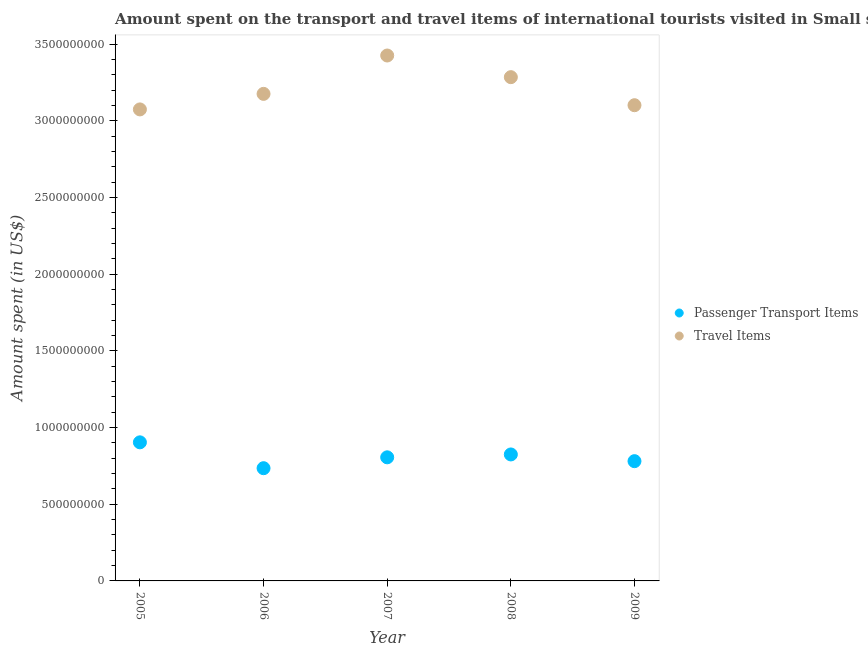How many different coloured dotlines are there?
Give a very brief answer. 2. What is the amount spent in travel items in 2008?
Offer a very short reply. 3.29e+09. Across all years, what is the maximum amount spent in travel items?
Offer a terse response. 3.43e+09. Across all years, what is the minimum amount spent in travel items?
Offer a very short reply. 3.08e+09. In which year was the amount spent in travel items minimum?
Your response must be concise. 2005. What is the total amount spent on passenger transport items in the graph?
Provide a succinct answer. 4.05e+09. What is the difference between the amount spent on passenger transport items in 2005 and that in 2007?
Ensure brevity in your answer.  9.78e+07. What is the difference between the amount spent on passenger transport items in 2005 and the amount spent in travel items in 2008?
Your answer should be compact. -2.38e+09. What is the average amount spent in travel items per year?
Provide a succinct answer. 3.21e+09. In the year 2006, what is the difference between the amount spent on passenger transport items and amount spent in travel items?
Offer a terse response. -2.44e+09. What is the ratio of the amount spent on passenger transport items in 2007 to that in 2009?
Give a very brief answer. 1.03. Is the amount spent in travel items in 2006 less than that in 2008?
Ensure brevity in your answer.  Yes. Is the difference between the amount spent in travel items in 2005 and 2008 greater than the difference between the amount spent on passenger transport items in 2005 and 2008?
Make the answer very short. No. What is the difference between the highest and the second highest amount spent on passenger transport items?
Ensure brevity in your answer.  7.90e+07. What is the difference between the highest and the lowest amount spent in travel items?
Your answer should be very brief. 3.52e+08. Does the amount spent in travel items monotonically increase over the years?
Your answer should be compact. No. Is the amount spent in travel items strictly greater than the amount spent on passenger transport items over the years?
Your answer should be very brief. Yes. Is the amount spent on passenger transport items strictly less than the amount spent in travel items over the years?
Your answer should be very brief. Yes. What is the difference between two consecutive major ticks on the Y-axis?
Your response must be concise. 5.00e+08. Are the values on the major ticks of Y-axis written in scientific E-notation?
Provide a short and direct response. No. Where does the legend appear in the graph?
Give a very brief answer. Center right. How many legend labels are there?
Your answer should be compact. 2. What is the title of the graph?
Your answer should be very brief. Amount spent on the transport and travel items of international tourists visited in Small states. What is the label or title of the X-axis?
Offer a very short reply. Year. What is the label or title of the Y-axis?
Offer a very short reply. Amount spent (in US$). What is the Amount spent (in US$) of Passenger Transport Items in 2005?
Give a very brief answer. 9.04e+08. What is the Amount spent (in US$) of Travel Items in 2005?
Ensure brevity in your answer.  3.08e+09. What is the Amount spent (in US$) in Passenger Transport Items in 2006?
Your answer should be compact. 7.35e+08. What is the Amount spent (in US$) in Travel Items in 2006?
Give a very brief answer. 3.18e+09. What is the Amount spent (in US$) of Passenger Transport Items in 2007?
Ensure brevity in your answer.  8.06e+08. What is the Amount spent (in US$) of Travel Items in 2007?
Your answer should be very brief. 3.43e+09. What is the Amount spent (in US$) of Passenger Transport Items in 2008?
Give a very brief answer. 8.25e+08. What is the Amount spent (in US$) of Travel Items in 2008?
Offer a very short reply. 3.29e+09. What is the Amount spent (in US$) in Passenger Transport Items in 2009?
Provide a short and direct response. 7.81e+08. What is the Amount spent (in US$) in Travel Items in 2009?
Offer a very short reply. 3.10e+09. Across all years, what is the maximum Amount spent (in US$) of Passenger Transport Items?
Your answer should be compact. 9.04e+08. Across all years, what is the maximum Amount spent (in US$) in Travel Items?
Ensure brevity in your answer.  3.43e+09. Across all years, what is the minimum Amount spent (in US$) of Passenger Transport Items?
Your answer should be compact. 7.35e+08. Across all years, what is the minimum Amount spent (in US$) in Travel Items?
Offer a terse response. 3.08e+09. What is the total Amount spent (in US$) of Passenger Transport Items in the graph?
Keep it short and to the point. 4.05e+09. What is the total Amount spent (in US$) in Travel Items in the graph?
Keep it short and to the point. 1.61e+1. What is the difference between the Amount spent (in US$) of Passenger Transport Items in 2005 and that in 2006?
Offer a very short reply. 1.69e+08. What is the difference between the Amount spent (in US$) of Travel Items in 2005 and that in 2006?
Provide a succinct answer. -1.01e+08. What is the difference between the Amount spent (in US$) in Passenger Transport Items in 2005 and that in 2007?
Your response must be concise. 9.78e+07. What is the difference between the Amount spent (in US$) in Travel Items in 2005 and that in 2007?
Ensure brevity in your answer.  -3.52e+08. What is the difference between the Amount spent (in US$) of Passenger Transport Items in 2005 and that in 2008?
Offer a terse response. 7.90e+07. What is the difference between the Amount spent (in US$) in Travel Items in 2005 and that in 2008?
Ensure brevity in your answer.  -2.10e+08. What is the difference between the Amount spent (in US$) in Passenger Transport Items in 2005 and that in 2009?
Offer a very short reply. 1.23e+08. What is the difference between the Amount spent (in US$) in Travel Items in 2005 and that in 2009?
Your response must be concise. -2.74e+07. What is the difference between the Amount spent (in US$) in Passenger Transport Items in 2006 and that in 2007?
Your answer should be compact. -7.09e+07. What is the difference between the Amount spent (in US$) of Travel Items in 2006 and that in 2007?
Offer a very short reply. -2.50e+08. What is the difference between the Amount spent (in US$) of Passenger Transport Items in 2006 and that in 2008?
Provide a short and direct response. -8.96e+07. What is the difference between the Amount spent (in US$) in Travel Items in 2006 and that in 2008?
Your answer should be compact. -1.09e+08. What is the difference between the Amount spent (in US$) of Passenger Transport Items in 2006 and that in 2009?
Your response must be concise. -4.59e+07. What is the difference between the Amount spent (in US$) in Travel Items in 2006 and that in 2009?
Give a very brief answer. 7.39e+07. What is the difference between the Amount spent (in US$) in Passenger Transport Items in 2007 and that in 2008?
Your answer should be very brief. -1.88e+07. What is the difference between the Amount spent (in US$) of Travel Items in 2007 and that in 2008?
Make the answer very short. 1.41e+08. What is the difference between the Amount spent (in US$) in Passenger Transport Items in 2007 and that in 2009?
Ensure brevity in your answer.  2.50e+07. What is the difference between the Amount spent (in US$) of Travel Items in 2007 and that in 2009?
Your answer should be compact. 3.24e+08. What is the difference between the Amount spent (in US$) of Passenger Transport Items in 2008 and that in 2009?
Offer a very short reply. 4.38e+07. What is the difference between the Amount spent (in US$) in Travel Items in 2008 and that in 2009?
Provide a short and direct response. 1.83e+08. What is the difference between the Amount spent (in US$) in Passenger Transport Items in 2005 and the Amount spent (in US$) in Travel Items in 2006?
Keep it short and to the point. -2.27e+09. What is the difference between the Amount spent (in US$) in Passenger Transport Items in 2005 and the Amount spent (in US$) in Travel Items in 2007?
Make the answer very short. -2.52e+09. What is the difference between the Amount spent (in US$) of Passenger Transport Items in 2005 and the Amount spent (in US$) of Travel Items in 2008?
Your answer should be very brief. -2.38e+09. What is the difference between the Amount spent (in US$) of Passenger Transport Items in 2005 and the Amount spent (in US$) of Travel Items in 2009?
Keep it short and to the point. -2.20e+09. What is the difference between the Amount spent (in US$) in Passenger Transport Items in 2006 and the Amount spent (in US$) in Travel Items in 2007?
Your response must be concise. -2.69e+09. What is the difference between the Amount spent (in US$) in Passenger Transport Items in 2006 and the Amount spent (in US$) in Travel Items in 2008?
Keep it short and to the point. -2.55e+09. What is the difference between the Amount spent (in US$) in Passenger Transport Items in 2006 and the Amount spent (in US$) in Travel Items in 2009?
Provide a succinct answer. -2.37e+09. What is the difference between the Amount spent (in US$) of Passenger Transport Items in 2007 and the Amount spent (in US$) of Travel Items in 2008?
Your answer should be compact. -2.48e+09. What is the difference between the Amount spent (in US$) of Passenger Transport Items in 2007 and the Amount spent (in US$) of Travel Items in 2009?
Keep it short and to the point. -2.30e+09. What is the difference between the Amount spent (in US$) of Passenger Transport Items in 2008 and the Amount spent (in US$) of Travel Items in 2009?
Give a very brief answer. -2.28e+09. What is the average Amount spent (in US$) in Passenger Transport Items per year?
Offer a very short reply. 8.10e+08. What is the average Amount spent (in US$) of Travel Items per year?
Give a very brief answer. 3.21e+09. In the year 2005, what is the difference between the Amount spent (in US$) of Passenger Transport Items and Amount spent (in US$) of Travel Items?
Offer a very short reply. -2.17e+09. In the year 2006, what is the difference between the Amount spent (in US$) in Passenger Transport Items and Amount spent (in US$) in Travel Items?
Give a very brief answer. -2.44e+09. In the year 2007, what is the difference between the Amount spent (in US$) in Passenger Transport Items and Amount spent (in US$) in Travel Items?
Make the answer very short. -2.62e+09. In the year 2008, what is the difference between the Amount spent (in US$) of Passenger Transport Items and Amount spent (in US$) of Travel Items?
Ensure brevity in your answer.  -2.46e+09. In the year 2009, what is the difference between the Amount spent (in US$) in Passenger Transport Items and Amount spent (in US$) in Travel Items?
Make the answer very short. -2.32e+09. What is the ratio of the Amount spent (in US$) of Passenger Transport Items in 2005 to that in 2006?
Make the answer very short. 1.23. What is the ratio of the Amount spent (in US$) of Travel Items in 2005 to that in 2006?
Make the answer very short. 0.97. What is the ratio of the Amount spent (in US$) of Passenger Transport Items in 2005 to that in 2007?
Your response must be concise. 1.12. What is the ratio of the Amount spent (in US$) of Travel Items in 2005 to that in 2007?
Provide a short and direct response. 0.9. What is the ratio of the Amount spent (in US$) in Passenger Transport Items in 2005 to that in 2008?
Keep it short and to the point. 1.1. What is the ratio of the Amount spent (in US$) in Travel Items in 2005 to that in 2008?
Your answer should be very brief. 0.94. What is the ratio of the Amount spent (in US$) of Passenger Transport Items in 2005 to that in 2009?
Your answer should be compact. 1.16. What is the ratio of the Amount spent (in US$) in Passenger Transport Items in 2006 to that in 2007?
Your answer should be very brief. 0.91. What is the ratio of the Amount spent (in US$) of Travel Items in 2006 to that in 2007?
Keep it short and to the point. 0.93. What is the ratio of the Amount spent (in US$) in Passenger Transport Items in 2006 to that in 2008?
Give a very brief answer. 0.89. What is the ratio of the Amount spent (in US$) of Travel Items in 2006 to that in 2008?
Give a very brief answer. 0.97. What is the ratio of the Amount spent (in US$) in Passenger Transport Items in 2006 to that in 2009?
Offer a terse response. 0.94. What is the ratio of the Amount spent (in US$) in Travel Items in 2006 to that in 2009?
Your response must be concise. 1.02. What is the ratio of the Amount spent (in US$) in Passenger Transport Items in 2007 to that in 2008?
Provide a succinct answer. 0.98. What is the ratio of the Amount spent (in US$) of Travel Items in 2007 to that in 2008?
Offer a very short reply. 1.04. What is the ratio of the Amount spent (in US$) of Passenger Transport Items in 2007 to that in 2009?
Provide a short and direct response. 1.03. What is the ratio of the Amount spent (in US$) in Travel Items in 2007 to that in 2009?
Provide a short and direct response. 1.1. What is the ratio of the Amount spent (in US$) of Passenger Transport Items in 2008 to that in 2009?
Your response must be concise. 1.06. What is the ratio of the Amount spent (in US$) of Travel Items in 2008 to that in 2009?
Give a very brief answer. 1.06. What is the difference between the highest and the second highest Amount spent (in US$) of Passenger Transport Items?
Keep it short and to the point. 7.90e+07. What is the difference between the highest and the second highest Amount spent (in US$) in Travel Items?
Your answer should be compact. 1.41e+08. What is the difference between the highest and the lowest Amount spent (in US$) of Passenger Transport Items?
Your answer should be very brief. 1.69e+08. What is the difference between the highest and the lowest Amount spent (in US$) of Travel Items?
Provide a short and direct response. 3.52e+08. 